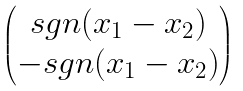<formula> <loc_0><loc_0><loc_500><loc_500>\begin{pmatrix} s g n ( x _ { 1 } - x _ { 2 } ) \\ - s g n ( x _ { 1 } - x _ { 2 } ) \end{pmatrix}</formula> 